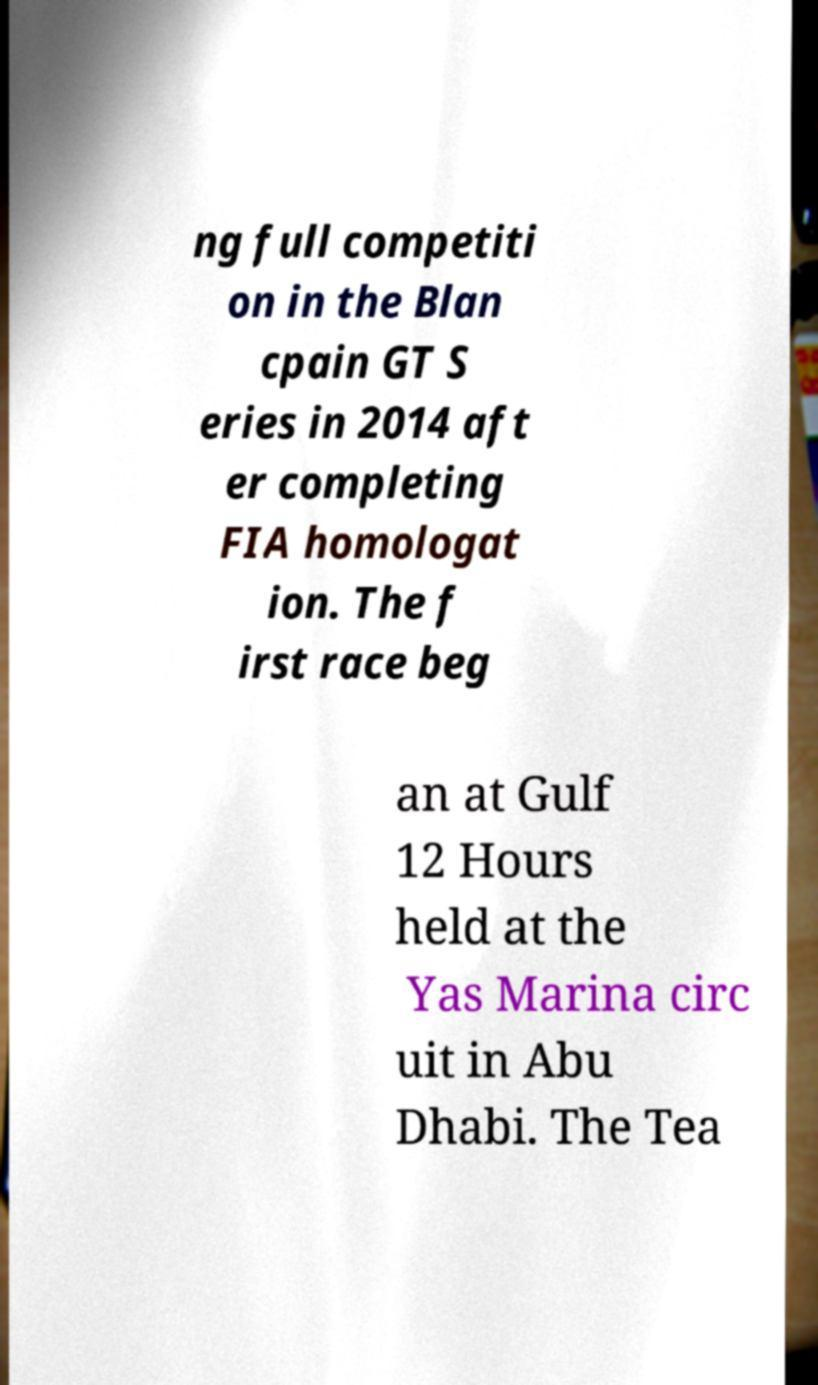For documentation purposes, I need the text within this image transcribed. Could you provide that? ng full competiti on in the Blan cpain GT S eries in 2014 aft er completing FIA homologat ion. The f irst race beg an at Gulf 12 Hours held at the Yas Marina circ uit in Abu Dhabi. The Tea 